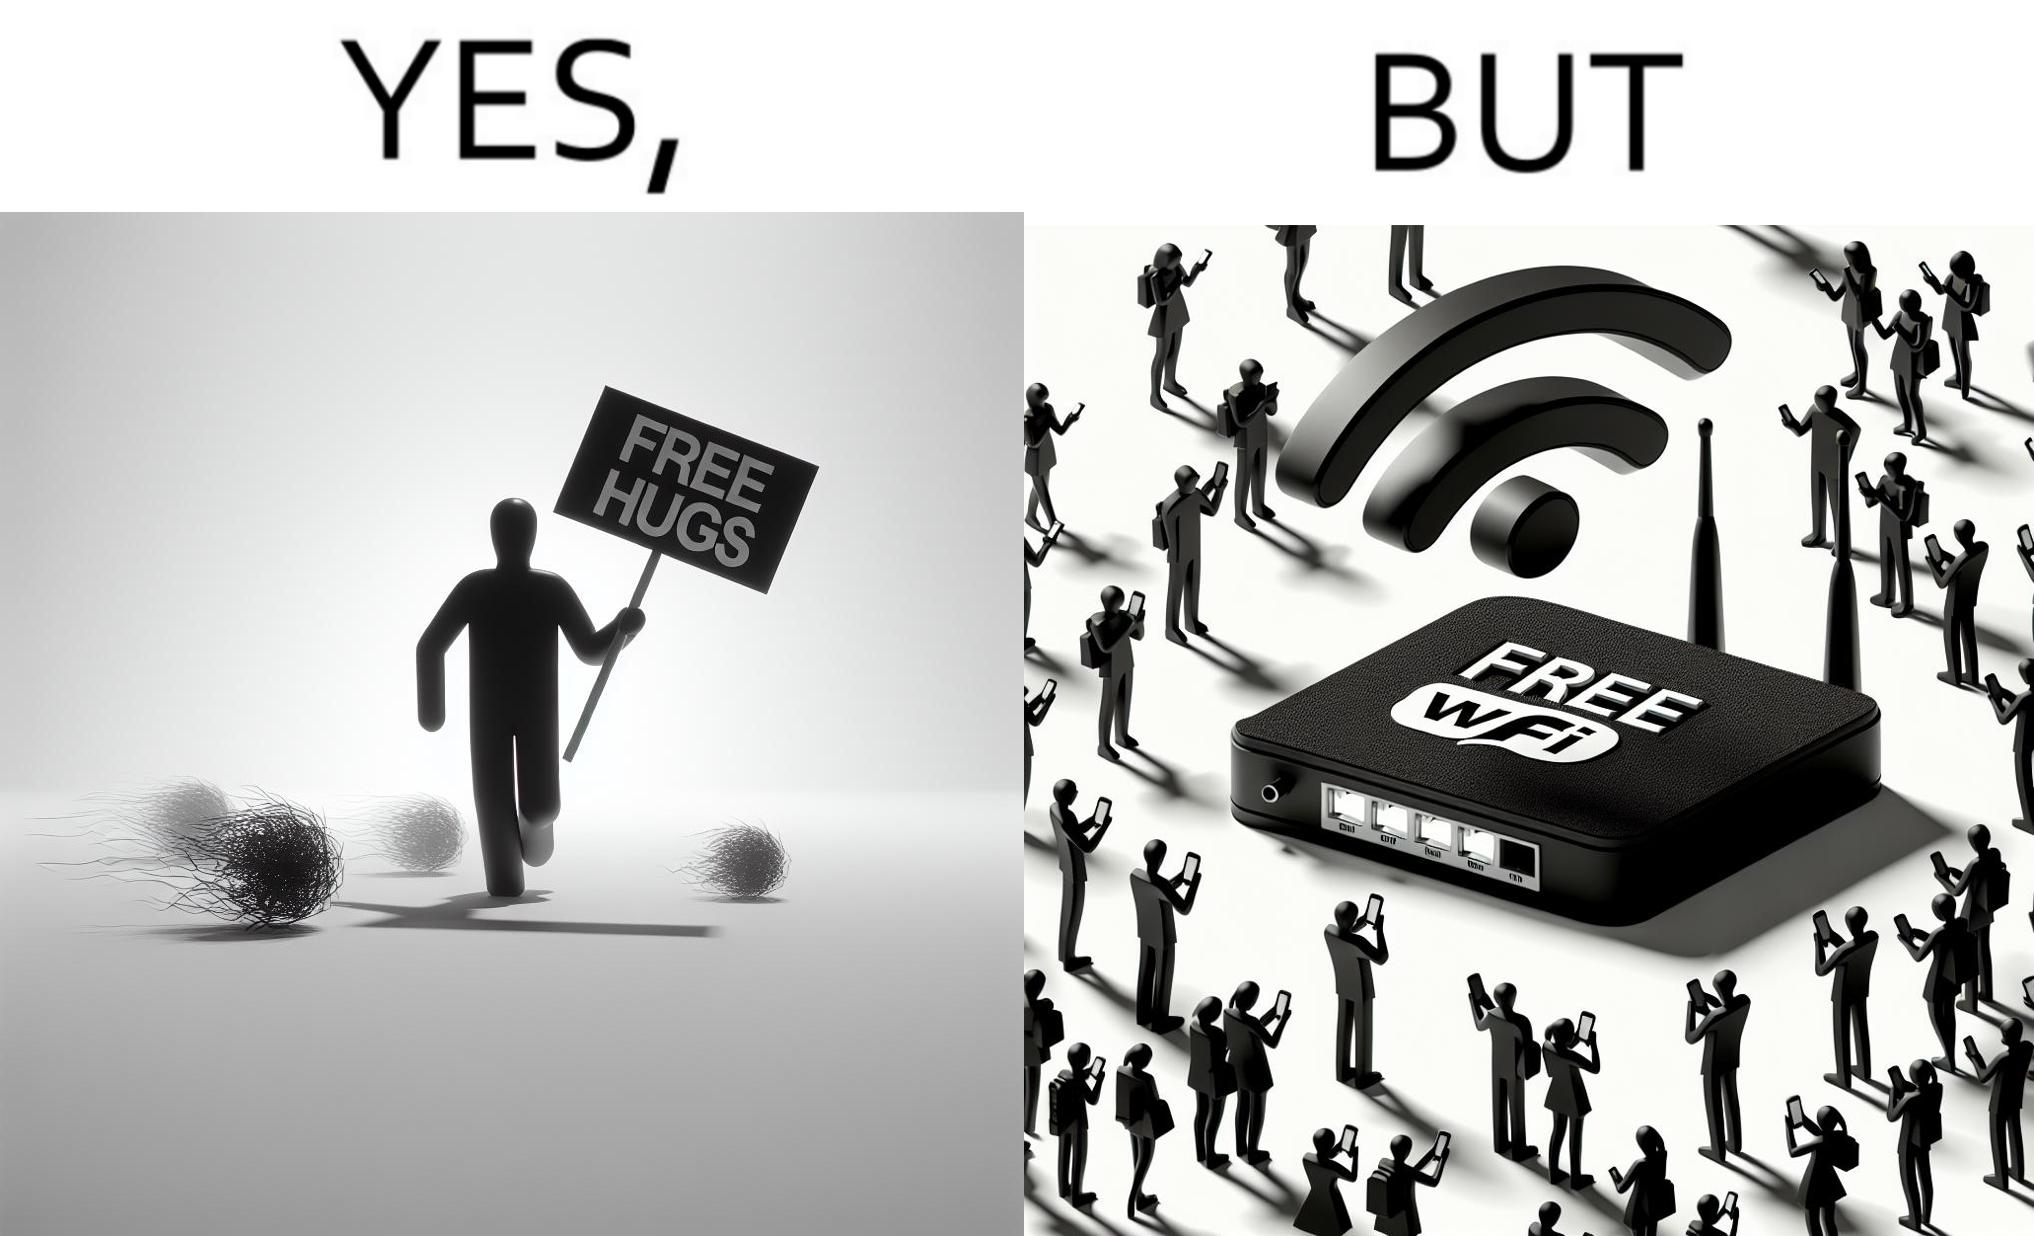What is shown in this image? This image is ironical, as a person holding up a "Free Hugs" sign is standing alone, while an inanimate Wi-fi Router giving "Free Wifi" is surrounded people trying to connect to it. This shows a growing lack of empathy in our society, while showing our increasing dependence on the digital devices in a virtual world. 